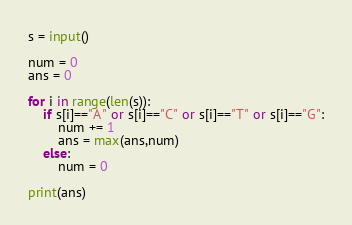Convert code to text. <code><loc_0><loc_0><loc_500><loc_500><_Python_>s = input()

num = 0
ans = 0

for i in range(len(s)):
    if s[i]=="A" or s[i]=="C" or s[i]=="T" or s[i]=="G":
        num += 1
        ans = max(ans,num)
    else:
        num = 0

print(ans)</code> 